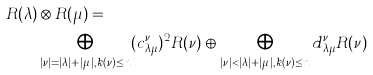<formula> <loc_0><loc_0><loc_500><loc_500>R ( \lambda ) & \otimes R ( \mu ) = \\ & \bigoplus _ { | \nu | = | \lambda | + | \mu | , k ( \nu ) \leq n } ( c _ { \lambda \mu } ^ { \nu } ) ^ { 2 } R ( \nu ) \oplus \bigoplus _ { | \nu | < | \lambda | + | \mu | , k ( \nu ) \leq n } d _ { \lambda \mu } ^ { \nu } R ( \nu )</formula> 